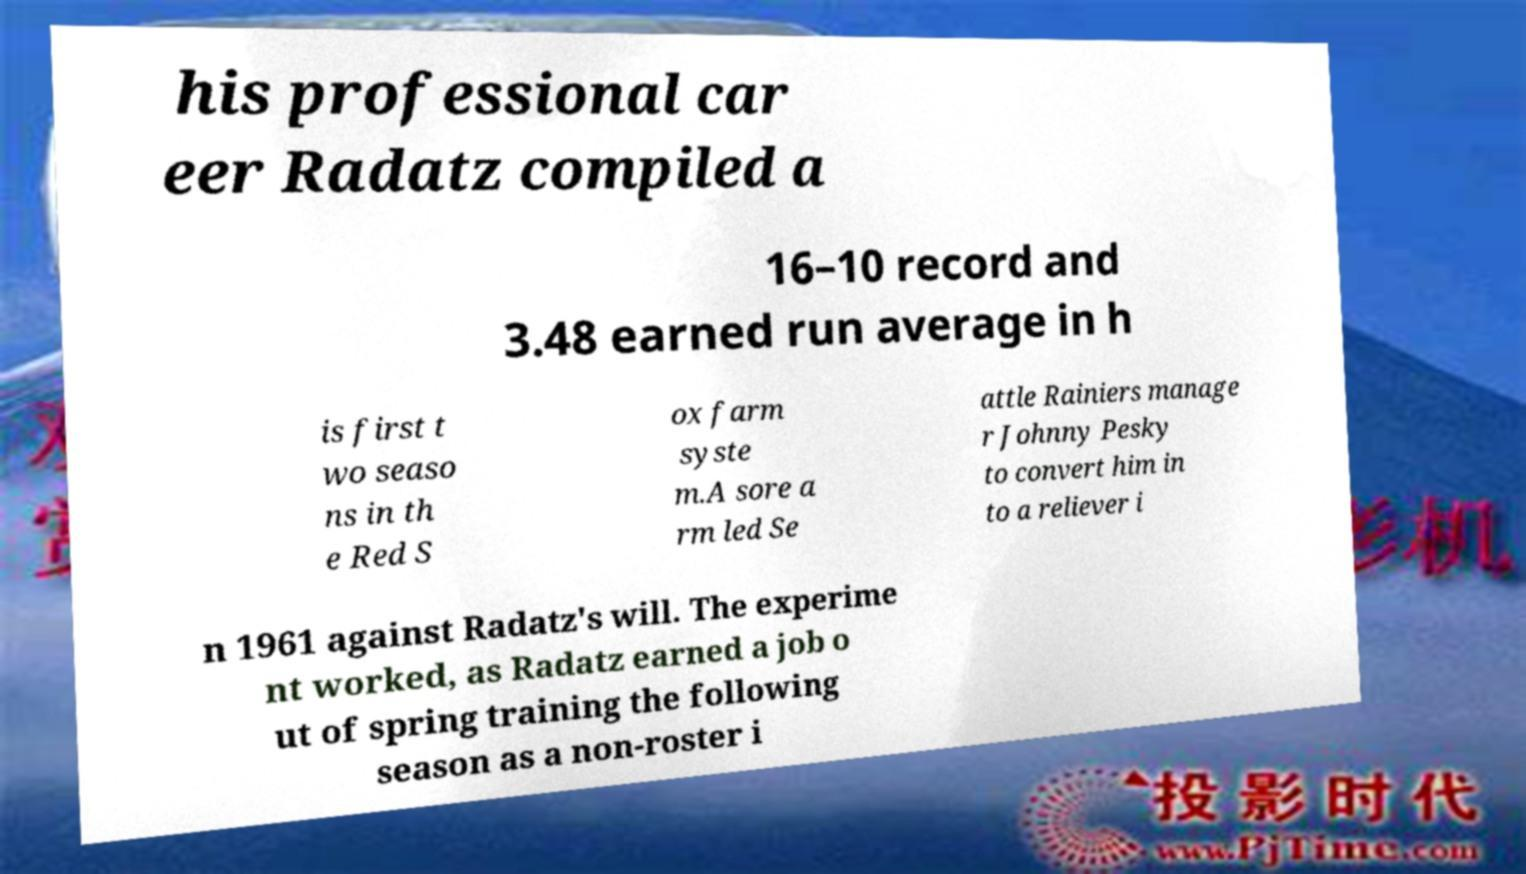Please read and relay the text visible in this image. What does it say? his professional car eer Radatz compiled a 16–10 record and 3.48 earned run average in h is first t wo seaso ns in th e Red S ox farm syste m.A sore a rm led Se attle Rainiers manage r Johnny Pesky to convert him in to a reliever i n 1961 against Radatz's will. The experime nt worked, as Radatz earned a job o ut of spring training the following season as a non-roster i 